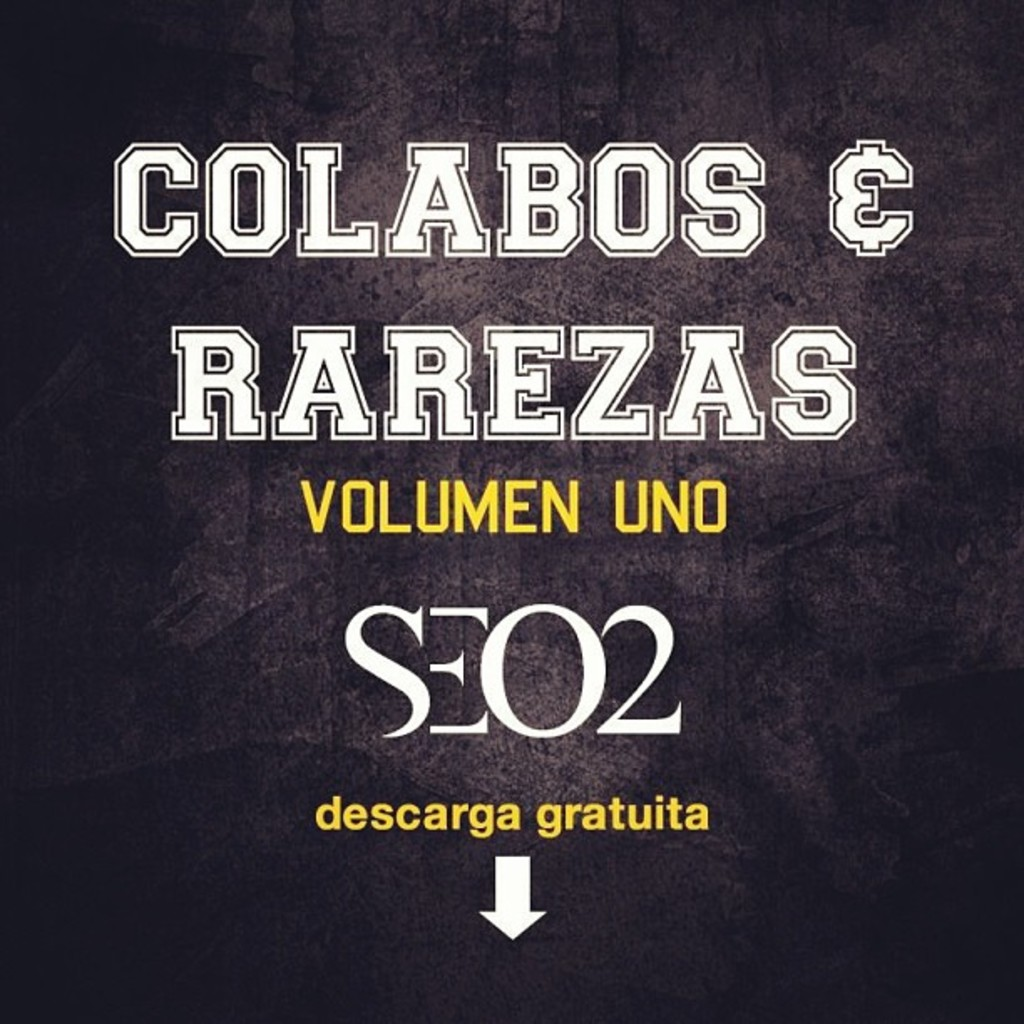What do you think is going on in this snapshot?
 The image presents the cover art for an album titled "Colabos & Rarezas Volumen Uno" by the artist SEO2. The background of the cover art is black, with the text displayed in white and yellow. The layout of the text places the album title at the top, the artist's name in the middle, and the phrase "descarga gratuita" at the bottom. The font used for the text is bold and sans-serif. An arrow pointing downwards at the bottom of the image suggests that the album is available for free download. 